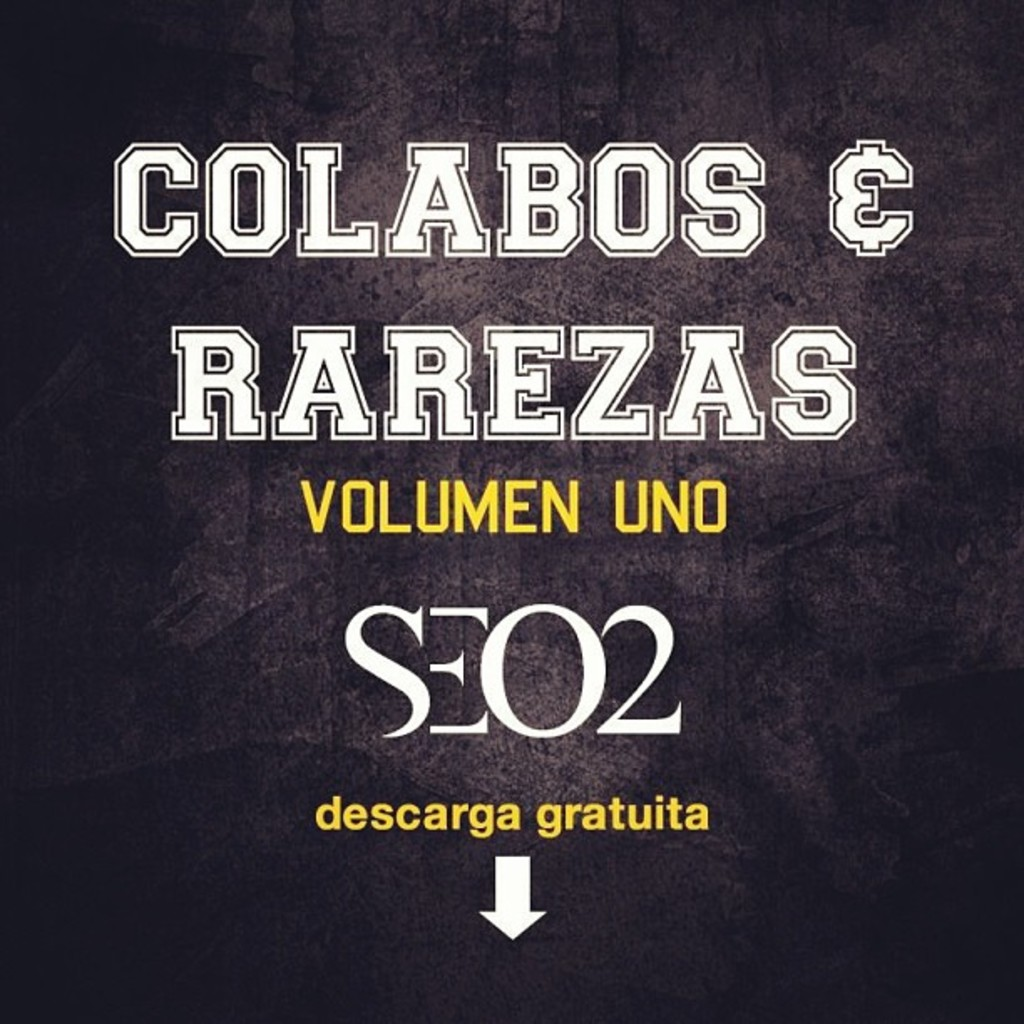What do you think is going on in this snapshot?
 The image presents the cover art for an album titled "Colabos & Rarezas Volumen Uno" by the artist SEO2. The background of the cover art is black, with the text displayed in white and yellow. The layout of the text places the album title at the top, the artist's name in the middle, and the phrase "descarga gratuita" at the bottom. The font used for the text is bold and sans-serif. An arrow pointing downwards at the bottom of the image suggests that the album is available for free download. 